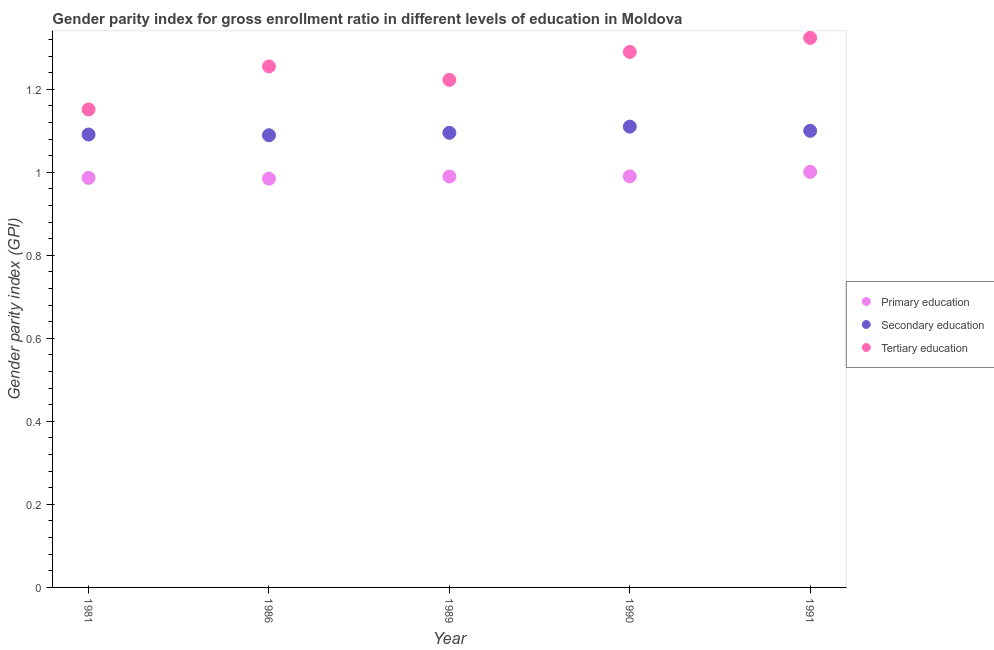What is the gender parity index in primary education in 1990?
Your answer should be very brief. 0.99. Across all years, what is the maximum gender parity index in primary education?
Your answer should be compact. 1. Across all years, what is the minimum gender parity index in tertiary education?
Keep it short and to the point. 1.15. What is the total gender parity index in secondary education in the graph?
Provide a succinct answer. 5.48. What is the difference between the gender parity index in tertiary education in 1981 and that in 1991?
Your answer should be compact. -0.17. What is the difference between the gender parity index in primary education in 1981 and the gender parity index in tertiary education in 1990?
Ensure brevity in your answer.  -0.3. What is the average gender parity index in tertiary education per year?
Your answer should be compact. 1.25. In the year 1990, what is the difference between the gender parity index in tertiary education and gender parity index in secondary education?
Provide a succinct answer. 0.18. What is the ratio of the gender parity index in tertiary education in 1981 to that in 1986?
Make the answer very short. 0.92. Is the difference between the gender parity index in secondary education in 1989 and 1991 greater than the difference between the gender parity index in tertiary education in 1989 and 1991?
Your response must be concise. Yes. What is the difference between the highest and the second highest gender parity index in secondary education?
Your answer should be compact. 0.01. What is the difference between the highest and the lowest gender parity index in primary education?
Your answer should be compact. 0.02. Is the sum of the gender parity index in primary education in 1986 and 1989 greater than the maximum gender parity index in secondary education across all years?
Offer a terse response. Yes. Is it the case that in every year, the sum of the gender parity index in primary education and gender parity index in secondary education is greater than the gender parity index in tertiary education?
Offer a very short reply. Yes. Does the gender parity index in secondary education monotonically increase over the years?
Ensure brevity in your answer.  No. Is the gender parity index in primary education strictly less than the gender parity index in secondary education over the years?
Ensure brevity in your answer.  Yes. How many dotlines are there?
Provide a succinct answer. 3. How many years are there in the graph?
Make the answer very short. 5. Are the values on the major ticks of Y-axis written in scientific E-notation?
Provide a short and direct response. No. Does the graph contain any zero values?
Give a very brief answer. No. Does the graph contain grids?
Provide a succinct answer. No. Where does the legend appear in the graph?
Your response must be concise. Center right. How many legend labels are there?
Give a very brief answer. 3. How are the legend labels stacked?
Make the answer very short. Vertical. What is the title of the graph?
Give a very brief answer. Gender parity index for gross enrollment ratio in different levels of education in Moldova. What is the label or title of the Y-axis?
Keep it short and to the point. Gender parity index (GPI). What is the Gender parity index (GPI) of Primary education in 1981?
Ensure brevity in your answer.  0.99. What is the Gender parity index (GPI) in Tertiary education in 1981?
Provide a short and direct response. 1.15. What is the Gender parity index (GPI) in Primary education in 1986?
Keep it short and to the point. 0.98. What is the Gender parity index (GPI) of Secondary education in 1986?
Offer a terse response. 1.09. What is the Gender parity index (GPI) of Tertiary education in 1986?
Your answer should be very brief. 1.25. What is the Gender parity index (GPI) in Primary education in 1989?
Offer a terse response. 0.99. What is the Gender parity index (GPI) of Secondary education in 1989?
Offer a terse response. 1.1. What is the Gender parity index (GPI) in Tertiary education in 1989?
Keep it short and to the point. 1.22. What is the Gender parity index (GPI) of Primary education in 1990?
Give a very brief answer. 0.99. What is the Gender parity index (GPI) in Secondary education in 1990?
Your answer should be compact. 1.11. What is the Gender parity index (GPI) in Tertiary education in 1990?
Give a very brief answer. 1.29. What is the Gender parity index (GPI) of Primary education in 1991?
Ensure brevity in your answer.  1. What is the Gender parity index (GPI) in Secondary education in 1991?
Provide a short and direct response. 1.1. What is the Gender parity index (GPI) of Tertiary education in 1991?
Your answer should be very brief. 1.32. Across all years, what is the maximum Gender parity index (GPI) of Primary education?
Your answer should be compact. 1. Across all years, what is the maximum Gender parity index (GPI) in Secondary education?
Ensure brevity in your answer.  1.11. Across all years, what is the maximum Gender parity index (GPI) in Tertiary education?
Provide a short and direct response. 1.32. Across all years, what is the minimum Gender parity index (GPI) of Primary education?
Your answer should be very brief. 0.98. Across all years, what is the minimum Gender parity index (GPI) of Secondary education?
Give a very brief answer. 1.09. Across all years, what is the minimum Gender parity index (GPI) of Tertiary education?
Give a very brief answer. 1.15. What is the total Gender parity index (GPI) in Primary education in the graph?
Offer a very short reply. 4.95. What is the total Gender parity index (GPI) of Secondary education in the graph?
Your answer should be very brief. 5.48. What is the total Gender parity index (GPI) in Tertiary education in the graph?
Make the answer very short. 6.24. What is the difference between the Gender parity index (GPI) of Primary education in 1981 and that in 1986?
Provide a succinct answer. 0. What is the difference between the Gender parity index (GPI) of Secondary education in 1981 and that in 1986?
Offer a terse response. 0. What is the difference between the Gender parity index (GPI) of Tertiary education in 1981 and that in 1986?
Give a very brief answer. -0.1. What is the difference between the Gender parity index (GPI) of Primary education in 1981 and that in 1989?
Keep it short and to the point. -0. What is the difference between the Gender parity index (GPI) of Secondary education in 1981 and that in 1989?
Offer a very short reply. -0. What is the difference between the Gender parity index (GPI) of Tertiary education in 1981 and that in 1989?
Provide a short and direct response. -0.07. What is the difference between the Gender parity index (GPI) of Primary education in 1981 and that in 1990?
Provide a succinct answer. -0. What is the difference between the Gender parity index (GPI) in Secondary education in 1981 and that in 1990?
Ensure brevity in your answer.  -0.02. What is the difference between the Gender parity index (GPI) in Tertiary education in 1981 and that in 1990?
Your answer should be compact. -0.14. What is the difference between the Gender parity index (GPI) in Primary education in 1981 and that in 1991?
Provide a succinct answer. -0.01. What is the difference between the Gender parity index (GPI) of Secondary education in 1981 and that in 1991?
Provide a short and direct response. -0.01. What is the difference between the Gender parity index (GPI) of Tertiary education in 1981 and that in 1991?
Keep it short and to the point. -0.17. What is the difference between the Gender parity index (GPI) of Primary education in 1986 and that in 1989?
Your response must be concise. -0.01. What is the difference between the Gender parity index (GPI) of Secondary education in 1986 and that in 1989?
Provide a short and direct response. -0.01. What is the difference between the Gender parity index (GPI) in Tertiary education in 1986 and that in 1989?
Make the answer very short. 0.03. What is the difference between the Gender parity index (GPI) of Primary education in 1986 and that in 1990?
Offer a very short reply. -0.01. What is the difference between the Gender parity index (GPI) in Secondary education in 1986 and that in 1990?
Your answer should be very brief. -0.02. What is the difference between the Gender parity index (GPI) of Tertiary education in 1986 and that in 1990?
Your answer should be very brief. -0.03. What is the difference between the Gender parity index (GPI) of Primary education in 1986 and that in 1991?
Keep it short and to the point. -0.02. What is the difference between the Gender parity index (GPI) of Secondary education in 1986 and that in 1991?
Your answer should be very brief. -0.01. What is the difference between the Gender parity index (GPI) of Tertiary education in 1986 and that in 1991?
Provide a short and direct response. -0.07. What is the difference between the Gender parity index (GPI) of Primary education in 1989 and that in 1990?
Ensure brevity in your answer.  -0. What is the difference between the Gender parity index (GPI) in Secondary education in 1989 and that in 1990?
Give a very brief answer. -0.01. What is the difference between the Gender parity index (GPI) of Tertiary education in 1989 and that in 1990?
Offer a very short reply. -0.07. What is the difference between the Gender parity index (GPI) of Primary education in 1989 and that in 1991?
Provide a succinct answer. -0.01. What is the difference between the Gender parity index (GPI) in Secondary education in 1989 and that in 1991?
Your answer should be compact. -0. What is the difference between the Gender parity index (GPI) in Tertiary education in 1989 and that in 1991?
Your response must be concise. -0.1. What is the difference between the Gender parity index (GPI) in Primary education in 1990 and that in 1991?
Make the answer very short. -0.01. What is the difference between the Gender parity index (GPI) of Secondary education in 1990 and that in 1991?
Your answer should be compact. 0.01. What is the difference between the Gender parity index (GPI) in Tertiary education in 1990 and that in 1991?
Give a very brief answer. -0.03. What is the difference between the Gender parity index (GPI) of Primary education in 1981 and the Gender parity index (GPI) of Secondary education in 1986?
Your answer should be compact. -0.1. What is the difference between the Gender parity index (GPI) of Primary education in 1981 and the Gender parity index (GPI) of Tertiary education in 1986?
Provide a succinct answer. -0.27. What is the difference between the Gender parity index (GPI) in Secondary education in 1981 and the Gender parity index (GPI) in Tertiary education in 1986?
Keep it short and to the point. -0.16. What is the difference between the Gender parity index (GPI) in Primary education in 1981 and the Gender parity index (GPI) in Secondary education in 1989?
Give a very brief answer. -0.11. What is the difference between the Gender parity index (GPI) of Primary education in 1981 and the Gender parity index (GPI) of Tertiary education in 1989?
Provide a short and direct response. -0.24. What is the difference between the Gender parity index (GPI) of Secondary education in 1981 and the Gender parity index (GPI) of Tertiary education in 1989?
Offer a very short reply. -0.13. What is the difference between the Gender parity index (GPI) of Primary education in 1981 and the Gender parity index (GPI) of Secondary education in 1990?
Offer a terse response. -0.12. What is the difference between the Gender parity index (GPI) in Primary education in 1981 and the Gender parity index (GPI) in Tertiary education in 1990?
Make the answer very short. -0.3. What is the difference between the Gender parity index (GPI) in Secondary education in 1981 and the Gender parity index (GPI) in Tertiary education in 1990?
Offer a terse response. -0.2. What is the difference between the Gender parity index (GPI) of Primary education in 1981 and the Gender parity index (GPI) of Secondary education in 1991?
Your answer should be compact. -0.11. What is the difference between the Gender parity index (GPI) of Primary education in 1981 and the Gender parity index (GPI) of Tertiary education in 1991?
Keep it short and to the point. -0.34. What is the difference between the Gender parity index (GPI) in Secondary education in 1981 and the Gender parity index (GPI) in Tertiary education in 1991?
Your response must be concise. -0.23. What is the difference between the Gender parity index (GPI) in Primary education in 1986 and the Gender parity index (GPI) in Secondary education in 1989?
Make the answer very short. -0.11. What is the difference between the Gender parity index (GPI) in Primary education in 1986 and the Gender parity index (GPI) in Tertiary education in 1989?
Offer a terse response. -0.24. What is the difference between the Gender parity index (GPI) of Secondary education in 1986 and the Gender parity index (GPI) of Tertiary education in 1989?
Offer a terse response. -0.13. What is the difference between the Gender parity index (GPI) in Primary education in 1986 and the Gender parity index (GPI) in Secondary education in 1990?
Provide a short and direct response. -0.13. What is the difference between the Gender parity index (GPI) in Primary education in 1986 and the Gender parity index (GPI) in Tertiary education in 1990?
Keep it short and to the point. -0.31. What is the difference between the Gender parity index (GPI) of Secondary education in 1986 and the Gender parity index (GPI) of Tertiary education in 1990?
Your answer should be compact. -0.2. What is the difference between the Gender parity index (GPI) of Primary education in 1986 and the Gender parity index (GPI) of Secondary education in 1991?
Provide a succinct answer. -0.12. What is the difference between the Gender parity index (GPI) in Primary education in 1986 and the Gender parity index (GPI) in Tertiary education in 1991?
Ensure brevity in your answer.  -0.34. What is the difference between the Gender parity index (GPI) in Secondary education in 1986 and the Gender parity index (GPI) in Tertiary education in 1991?
Ensure brevity in your answer.  -0.23. What is the difference between the Gender parity index (GPI) of Primary education in 1989 and the Gender parity index (GPI) of Secondary education in 1990?
Provide a succinct answer. -0.12. What is the difference between the Gender parity index (GPI) of Primary education in 1989 and the Gender parity index (GPI) of Tertiary education in 1990?
Provide a succinct answer. -0.3. What is the difference between the Gender parity index (GPI) of Secondary education in 1989 and the Gender parity index (GPI) of Tertiary education in 1990?
Make the answer very short. -0.19. What is the difference between the Gender parity index (GPI) of Primary education in 1989 and the Gender parity index (GPI) of Secondary education in 1991?
Offer a very short reply. -0.11. What is the difference between the Gender parity index (GPI) in Primary education in 1989 and the Gender parity index (GPI) in Tertiary education in 1991?
Keep it short and to the point. -0.33. What is the difference between the Gender parity index (GPI) of Secondary education in 1989 and the Gender parity index (GPI) of Tertiary education in 1991?
Make the answer very short. -0.23. What is the difference between the Gender parity index (GPI) of Primary education in 1990 and the Gender parity index (GPI) of Secondary education in 1991?
Provide a short and direct response. -0.11. What is the difference between the Gender parity index (GPI) of Primary education in 1990 and the Gender parity index (GPI) of Tertiary education in 1991?
Give a very brief answer. -0.33. What is the difference between the Gender parity index (GPI) of Secondary education in 1990 and the Gender parity index (GPI) of Tertiary education in 1991?
Ensure brevity in your answer.  -0.21. What is the average Gender parity index (GPI) in Primary education per year?
Your answer should be compact. 0.99. What is the average Gender parity index (GPI) in Secondary education per year?
Give a very brief answer. 1.1. What is the average Gender parity index (GPI) in Tertiary education per year?
Ensure brevity in your answer.  1.25. In the year 1981, what is the difference between the Gender parity index (GPI) in Primary education and Gender parity index (GPI) in Secondary education?
Make the answer very short. -0.1. In the year 1981, what is the difference between the Gender parity index (GPI) of Primary education and Gender parity index (GPI) of Tertiary education?
Offer a very short reply. -0.17. In the year 1981, what is the difference between the Gender parity index (GPI) in Secondary education and Gender parity index (GPI) in Tertiary education?
Give a very brief answer. -0.06. In the year 1986, what is the difference between the Gender parity index (GPI) in Primary education and Gender parity index (GPI) in Secondary education?
Your answer should be compact. -0.1. In the year 1986, what is the difference between the Gender parity index (GPI) in Primary education and Gender parity index (GPI) in Tertiary education?
Provide a short and direct response. -0.27. In the year 1986, what is the difference between the Gender parity index (GPI) in Secondary education and Gender parity index (GPI) in Tertiary education?
Give a very brief answer. -0.17. In the year 1989, what is the difference between the Gender parity index (GPI) in Primary education and Gender parity index (GPI) in Secondary education?
Make the answer very short. -0.11. In the year 1989, what is the difference between the Gender parity index (GPI) of Primary education and Gender parity index (GPI) of Tertiary education?
Your answer should be compact. -0.23. In the year 1989, what is the difference between the Gender parity index (GPI) of Secondary education and Gender parity index (GPI) of Tertiary education?
Your response must be concise. -0.13. In the year 1990, what is the difference between the Gender parity index (GPI) of Primary education and Gender parity index (GPI) of Secondary education?
Your response must be concise. -0.12. In the year 1990, what is the difference between the Gender parity index (GPI) of Primary education and Gender parity index (GPI) of Tertiary education?
Your answer should be very brief. -0.3. In the year 1990, what is the difference between the Gender parity index (GPI) in Secondary education and Gender parity index (GPI) in Tertiary education?
Your answer should be compact. -0.18. In the year 1991, what is the difference between the Gender parity index (GPI) in Primary education and Gender parity index (GPI) in Secondary education?
Provide a short and direct response. -0.1. In the year 1991, what is the difference between the Gender parity index (GPI) of Primary education and Gender parity index (GPI) of Tertiary education?
Offer a very short reply. -0.32. In the year 1991, what is the difference between the Gender parity index (GPI) of Secondary education and Gender parity index (GPI) of Tertiary education?
Make the answer very short. -0.22. What is the ratio of the Gender parity index (GPI) in Tertiary education in 1981 to that in 1986?
Ensure brevity in your answer.  0.92. What is the ratio of the Gender parity index (GPI) of Primary education in 1981 to that in 1989?
Keep it short and to the point. 1. What is the ratio of the Gender parity index (GPI) of Secondary education in 1981 to that in 1989?
Your answer should be compact. 1. What is the ratio of the Gender parity index (GPI) in Tertiary education in 1981 to that in 1989?
Provide a succinct answer. 0.94. What is the ratio of the Gender parity index (GPI) in Secondary education in 1981 to that in 1990?
Offer a terse response. 0.98. What is the ratio of the Gender parity index (GPI) in Tertiary education in 1981 to that in 1990?
Offer a terse response. 0.89. What is the ratio of the Gender parity index (GPI) of Primary education in 1981 to that in 1991?
Offer a very short reply. 0.99. What is the ratio of the Gender parity index (GPI) in Secondary education in 1981 to that in 1991?
Your response must be concise. 0.99. What is the ratio of the Gender parity index (GPI) of Tertiary education in 1981 to that in 1991?
Your answer should be compact. 0.87. What is the ratio of the Gender parity index (GPI) in Primary education in 1986 to that in 1989?
Provide a succinct answer. 0.99. What is the ratio of the Gender parity index (GPI) in Secondary education in 1986 to that in 1989?
Make the answer very short. 0.99. What is the ratio of the Gender parity index (GPI) of Tertiary education in 1986 to that in 1989?
Keep it short and to the point. 1.03. What is the ratio of the Gender parity index (GPI) of Primary education in 1986 to that in 1990?
Provide a succinct answer. 0.99. What is the ratio of the Gender parity index (GPI) of Secondary education in 1986 to that in 1990?
Offer a terse response. 0.98. What is the ratio of the Gender parity index (GPI) in Tertiary education in 1986 to that in 1990?
Your answer should be very brief. 0.97. What is the ratio of the Gender parity index (GPI) in Primary education in 1986 to that in 1991?
Keep it short and to the point. 0.98. What is the ratio of the Gender parity index (GPI) in Secondary education in 1986 to that in 1991?
Your answer should be very brief. 0.99. What is the ratio of the Gender parity index (GPI) of Tertiary education in 1986 to that in 1991?
Your answer should be compact. 0.95. What is the ratio of the Gender parity index (GPI) of Primary education in 1989 to that in 1990?
Provide a short and direct response. 1. What is the ratio of the Gender parity index (GPI) in Secondary education in 1989 to that in 1990?
Make the answer very short. 0.99. What is the ratio of the Gender parity index (GPI) of Tertiary education in 1989 to that in 1990?
Your answer should be very brief. 0.95. What is the ratio of the Gender parity index (GPI) of Primary education in 1989 to that in 1991?
Offer a terse response. 0.99. What is the ratio of the Gender parity index (GPI) of Tertiary education in 1989 to that in 1991?
Provide a succinct answer. 0.92. What is the ratio of the Gender parity index (GPI) of Primary education in 1990 to that in 1991?
Ensure brevity in your answer.  0.99. What is the ratio of the Gender parity index (GPI) in Secondary education in 1990 to that in 1991?
Provide a succinct answer. 1.01. What is the ratio of the Gender parity index (GPI) of Tertiary education in 1990 to that in 1991?
Give a very brief answer. 0.97. What is the difference between the highest and the second highest Gender parity index (GPI) in Primary education?
Your answer should be very brief. 0.01. What is the difference between the highest and the second highest Gender parity index (GPI) of Secondary education?
Offer a terse response. 0.01. What is the difference between the highest and the second highest Gender parity index (GPI) in Tertiary education?
Make the answer very short. 0.03. What is the difference between the highest and the lowest Gender parity index (GPI) of Primary education?
Give a very brief answer. 0.02. What is the difference between the highest and the lowest Gender parity index (GPI) of Secondary education?
Offer a very short reply. 0.02. What is the difference between the highest and the lowest Gender parity index (GPI) of Tertiary education?
Ensure brevity in your answer.  0.17. 